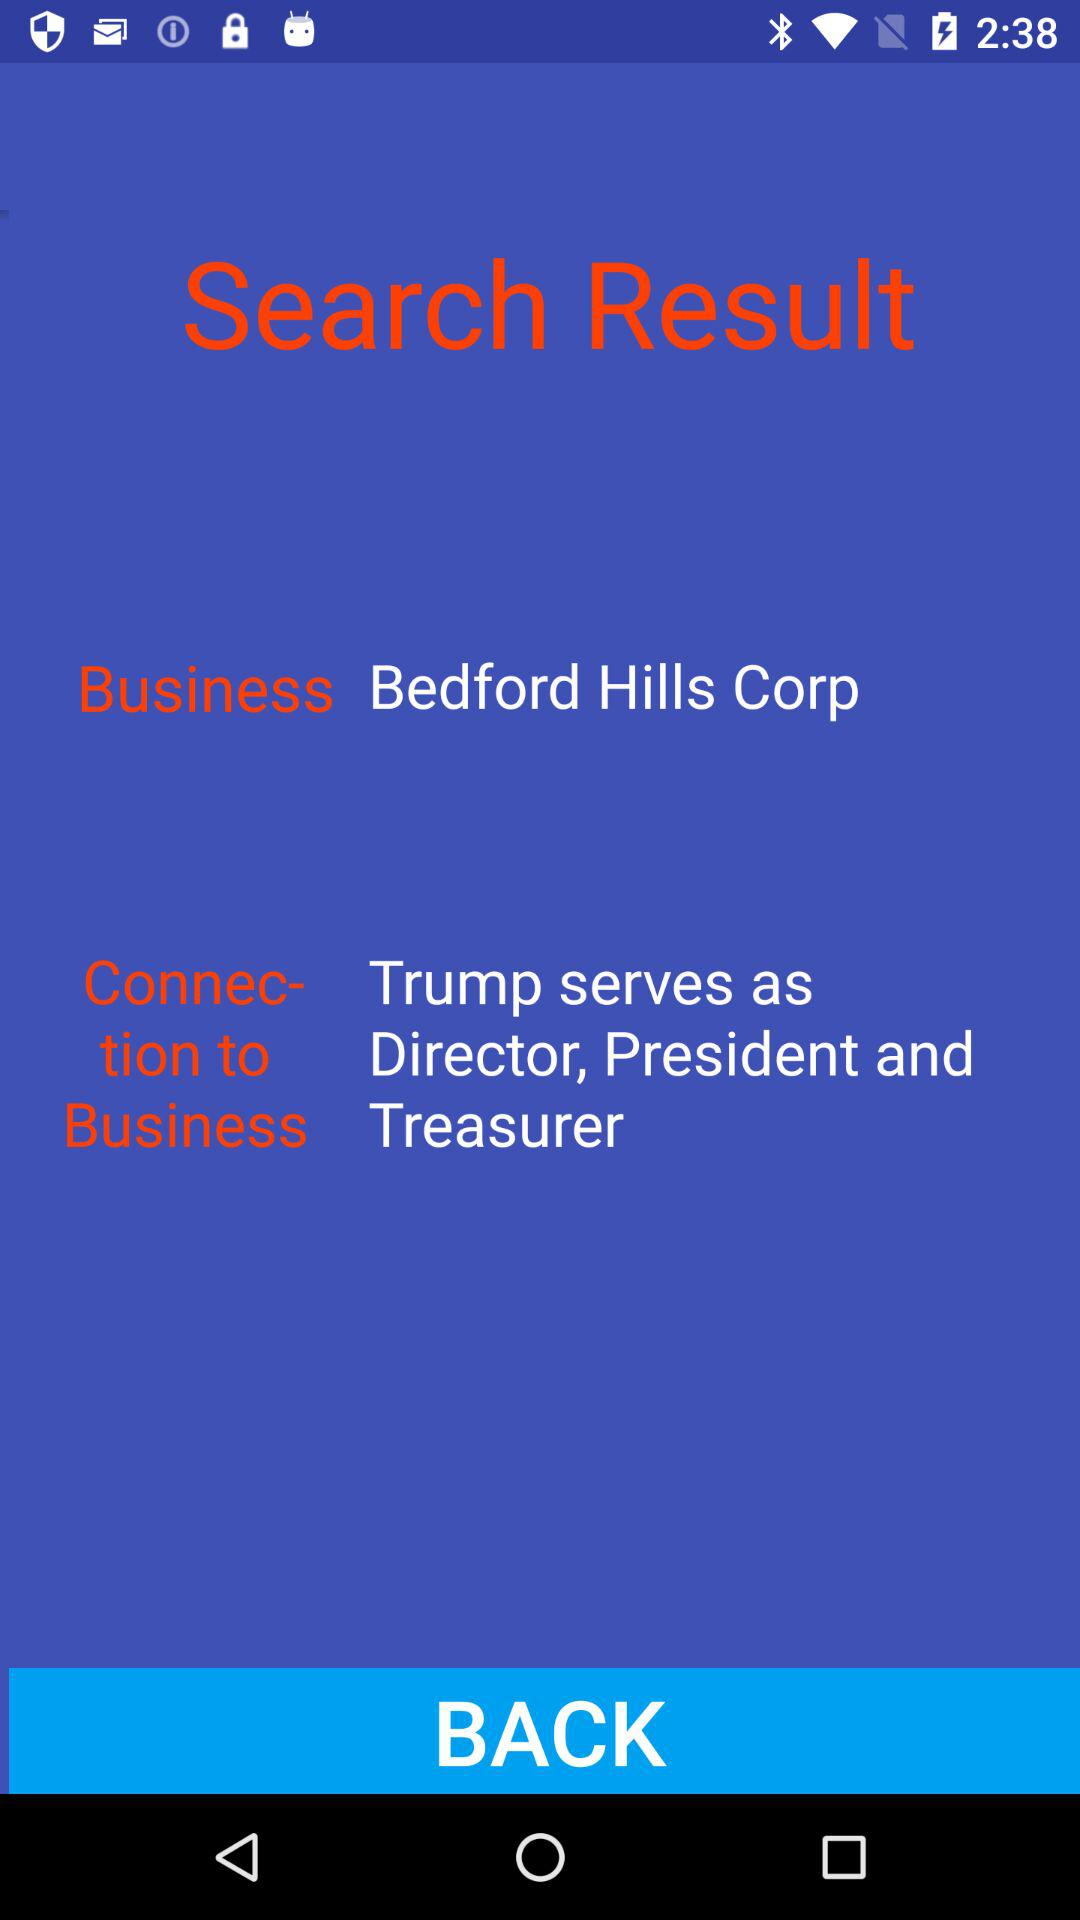Who is the director? The director is Trump. 